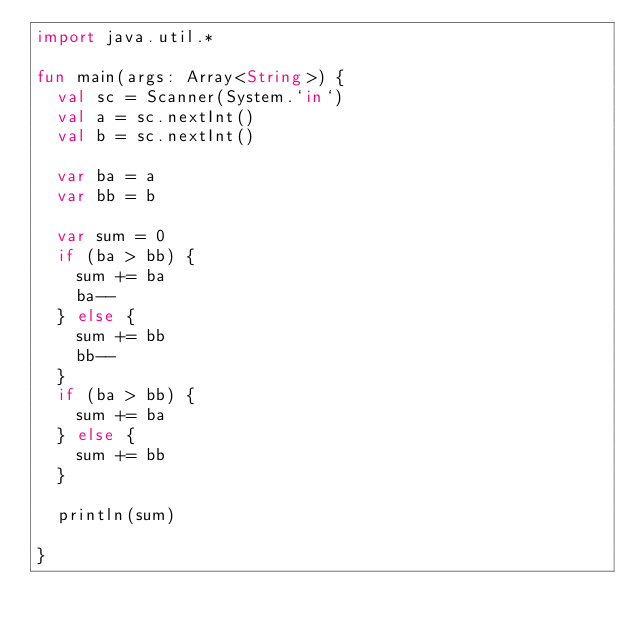Convert code to text. <code><loc_0><loc_0><loc_500><loc_500><_Kotlin_>import java.util.*

fun main(args: Array<String>) {
  val sc = Scanner(System.`in`)
  val a = sc.nextInt()
  val b = sc.nextInt()

  var ba = a
  var bb = b

  var sum = 0
  if (ba > bb) {
    sum += ba
    ba--
  } else {
    sum += bb
    bb--
  }
  if (ba > bb) {
    sum += ba
  } else {
    sum += bb
  }

  println(sum)

}
</code> 